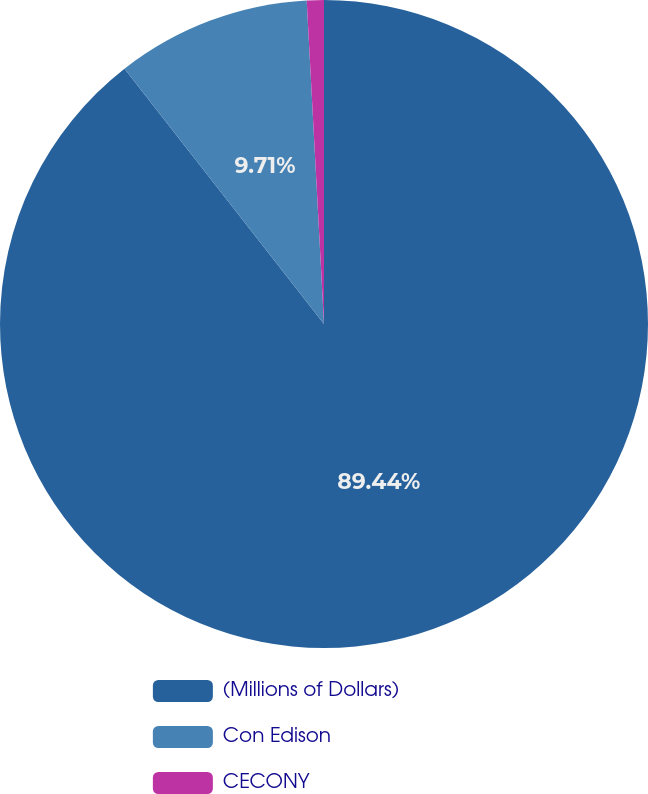<chart> <loc_0><loc_0><loc_500><loc_500><pie_chart><fcel>(Millions of Dollars)<fcel>Con Edison<fcel>CECONY<nl><fcel>89.45%<fcel>9.71%<fcel>0.85%<nl></chart> 